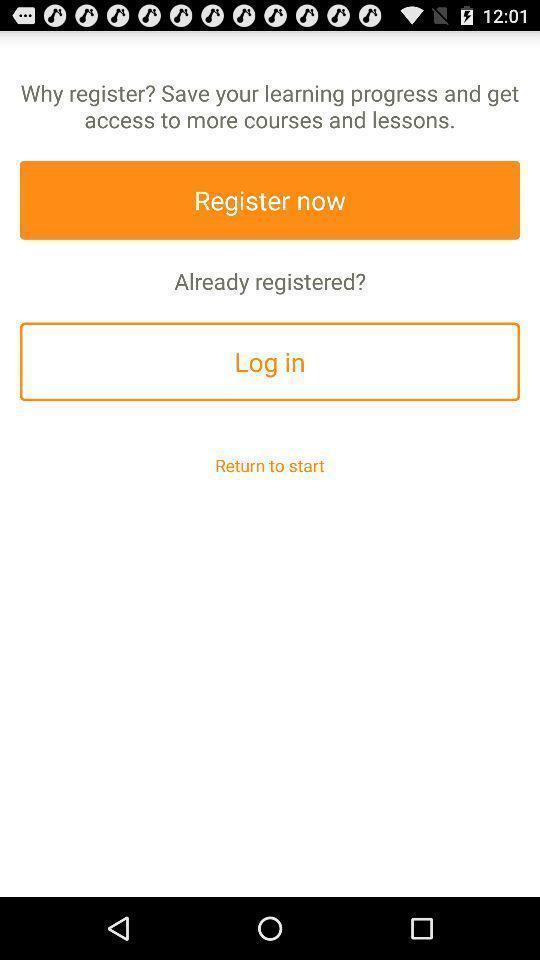What is the overall content of this screenshot? Welcome to the sign in page. 